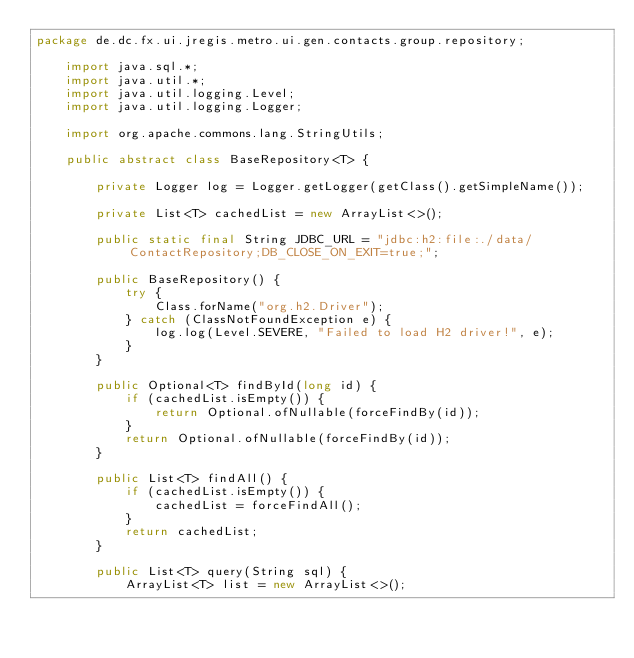Convert code to text. <code><loc_0><loc_0><loc_500><loc_500><_Java_>package de.dc.fx.ui.jregis.metro.ui.gen.contacts.group.repository;
	
	import java.sql.*;
	import java.util.*;
	import java.util.logging.Level;
	import java.util.logging.Logger;
	
	import org.apache.commons.lang.StringUtils;
	
	public abstract class BaseRepository<T> {
	
		private Logger log = Logger.getLogger(getClass().getSimpleName());
	
		private List<T> cachedList = new ArrayList<>();
	
		public static final String JDBC_URL = "jdbc:h2:file:./data/ContactRepository;DB_CLOSE_ON_EXIT=true;";
		
		public BaseRepository() {
			try {
				Class.forName("org.h2.Driver");
			} catch (ClassNotFoundException e) {
				log.log(Level.SEVERE, "Failed to load H2 driver!", e);
			}
		}
	
		public Optional<T> findById(long id) {
			if (cachedList.isEmpty()) {
				return Optional.ofNullable(forceFindBy(id));
			}
			return Optional.ofNullable(forceFindBy(id));
		}
	
		public List<T> findAll() {
			if (cachedList.isEmpty()) {
				cachedList = forceFindAll();
			}
			return cachedList;
		}
	
		public List<T> query(String sql) {
			ArrayList<T> list = new ArrayList<>();</code> 